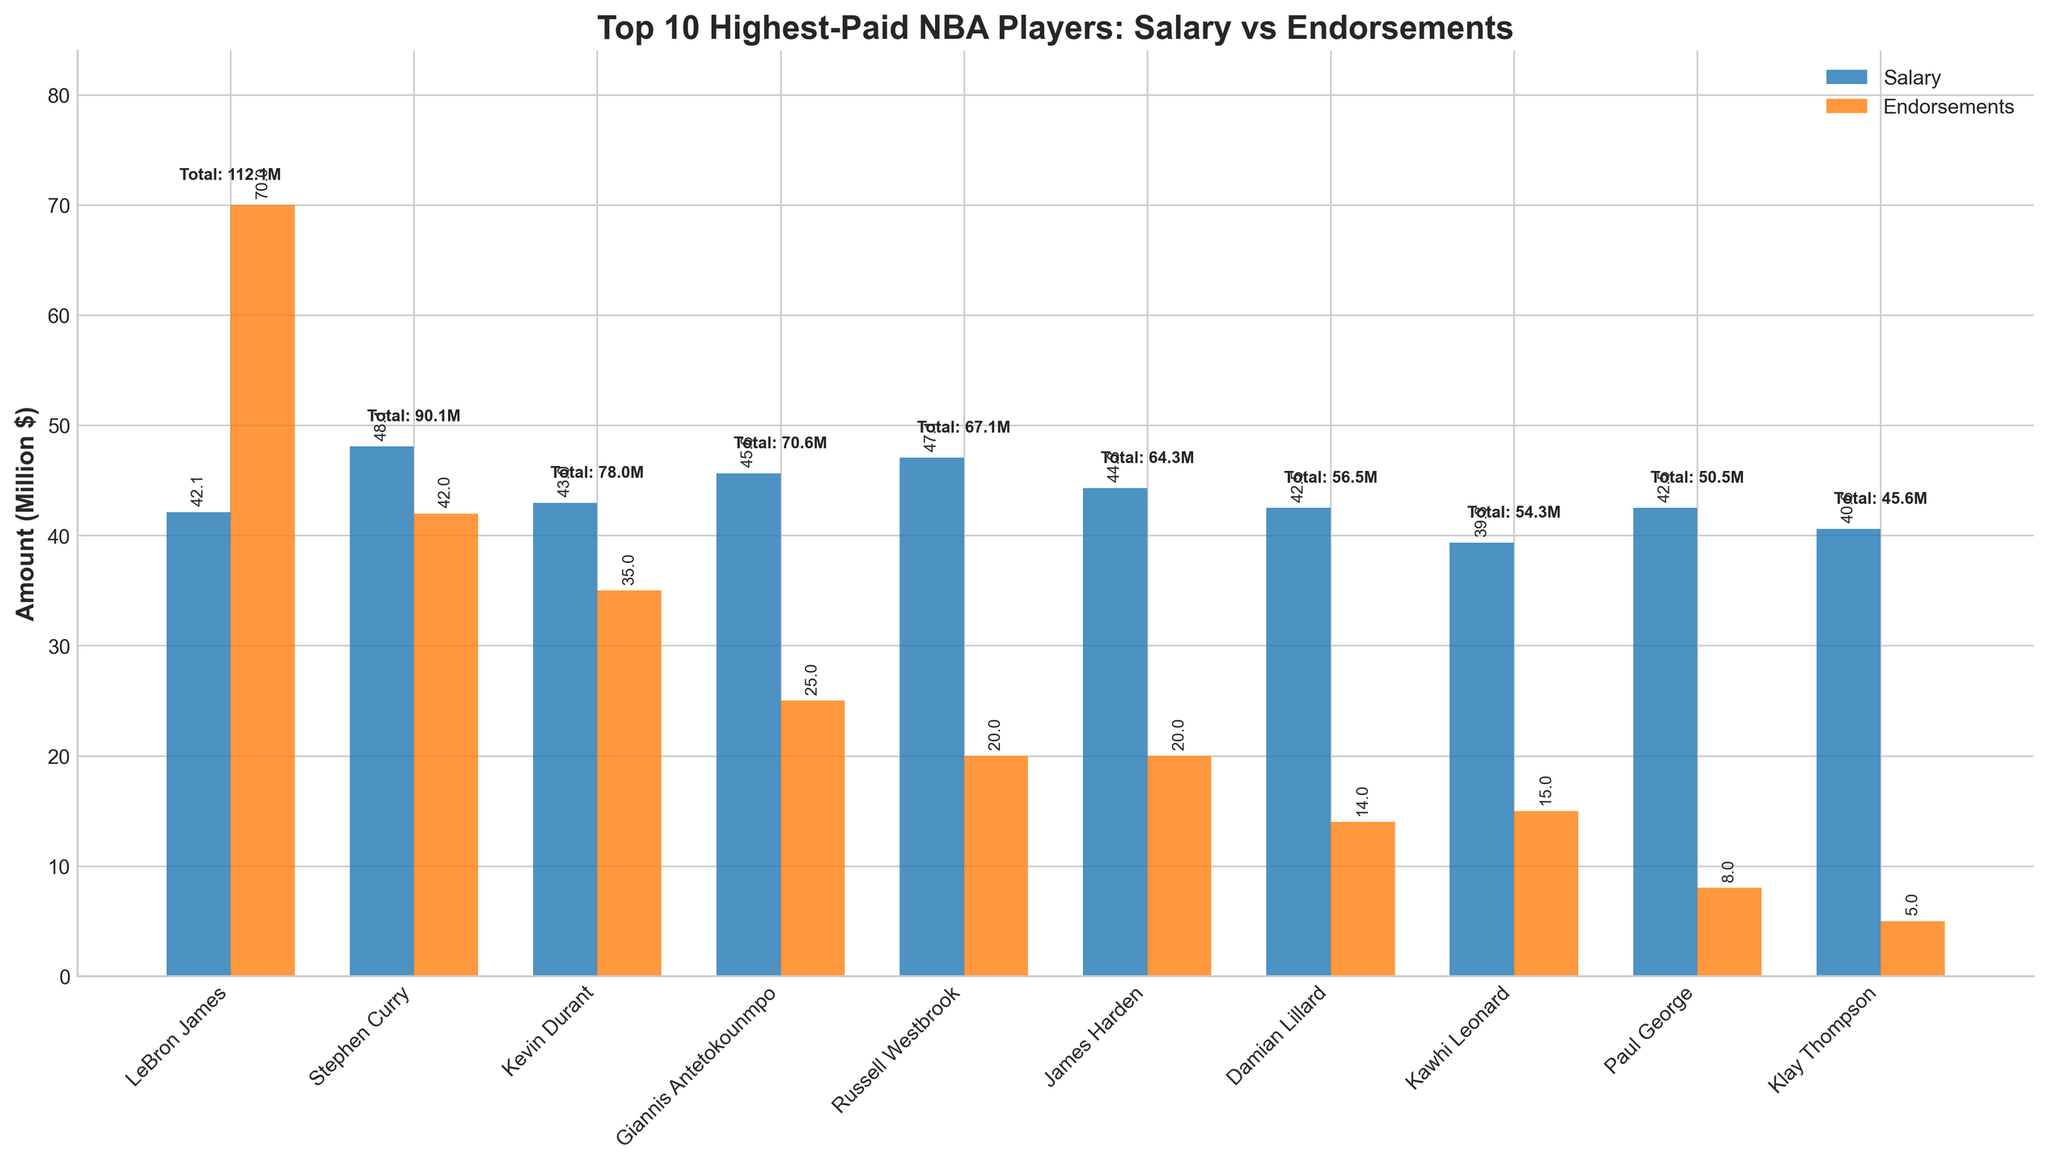Which player has the highest total contract value? To determine the player with the highest total contract value, look at the y-axis labels of the bars labeled “Total Contract Value”. Identify the tallest bar among all, representing LeBron James.
Answer: LeBron James How much more does LeBron James earn from endorsements compared to Stephen Curry? LeBron James earns $70 million from endorsements, whereas Stephen Curry earns $42 million from endorsements. Subtract Curry's endorsement earnings from James’s to get the difference: $70M - $42M = $28M.
Answer: $28M Which player has the smallest salary earnings among the top 10, and what is that amount? Look for the shortest bar labeled “Salary”. Paul George and Damian Lillard have the smallest salary earnings, each with a value close to $42.492492M. As they have the same value, either of them can be considered.
Answer: Paul George ($42.492492M) What is the average salary of the top five highest-paid players? Identify the top five players (LeBron James, Stephen Curry, Kevin Durant, Giannis Antetokounmpo, and Russell Westbrook) and list their salaries: $42.1M, $48.07M, $42.97M, $45.64M, and $47.063478M. Calculate the average: (42.1 + 48.07 + 42.97 + 45.64 + 47.063478) / 5 = $45.1687M.
Answer: $45.1687M Who earns more from endorsements than from their salary, and by how much? Compare the bar heights of “Salary” and “Endorsements” for each player. LeBron James, whose endorsement bar ($70M) is higher than the salary bar ($42.1M). The difference: $70M - $42.1M = $27.9M.
Answer: LeBron James, $27.9M Which player has the highest total earnings from salary and endorsements combined, and what is the total amount? The player with the highest total earnings is indicated by the text displaying the total value above the bars. LeBron James has the highest combined earnings of $112.1M.
Answer: LeBron James, $112.1M What is the difference in total contract value between the highest and lowest paid players? Identify LeBron James as the highest-paid at $112.1M, and Klay Thompson as the lowest-paid at $45.6M. The difference: $112.1M - $45.6M = $66.5M.
Answer: $66.5M How do the total earnings of Giannis Antetokounmpo compare to James Harden? Giannis Antetokounmpo has a total contract value of $70.64M, and James Harden $64.31M. Comparing these amounts shows Giannis earns more.
Answer: Giannis Antetokounmpo earns more What is the combined total contract value of all the players shown in the figure? Summing all players' total contract values: $112.1M + $90.07M + $77.97M + $70.64M + $67.06M + $64.31M + $56.49M + $54.34M + $50.49M + $45.6M = $689.07M.
Answer: $689.07M 